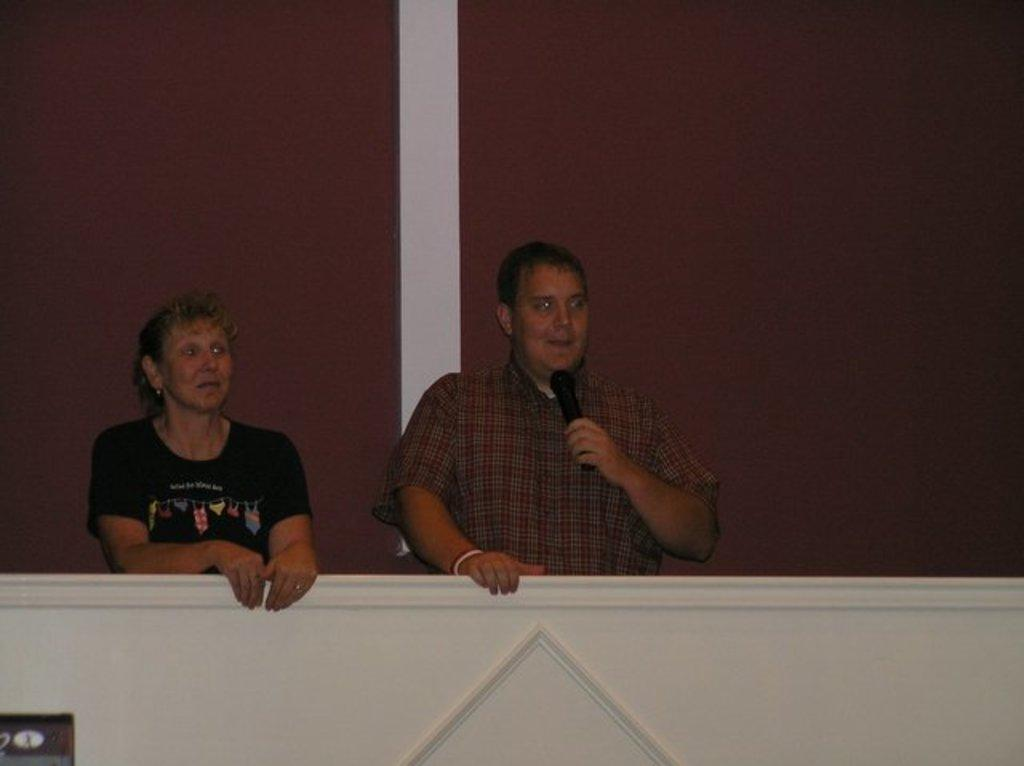What type of structure can be seen in the image? There is railing in the image, which suggests a structure like stairs or a balcony. What object is present that might be used for amplifying sound? There is a microphone (mike) in the image. Can you describe the people in the image? There are people in the image, but their specific actions or appearances are not mentioned in the provided facts. How many ladybugs are crawling on the railing in the image? There is no mention of ladybugs in the provided facts, so we cannot determine their presence or number in the image. What type of bread is being used as a beam in the image? There is no beam or loaf of bread present in the image. 